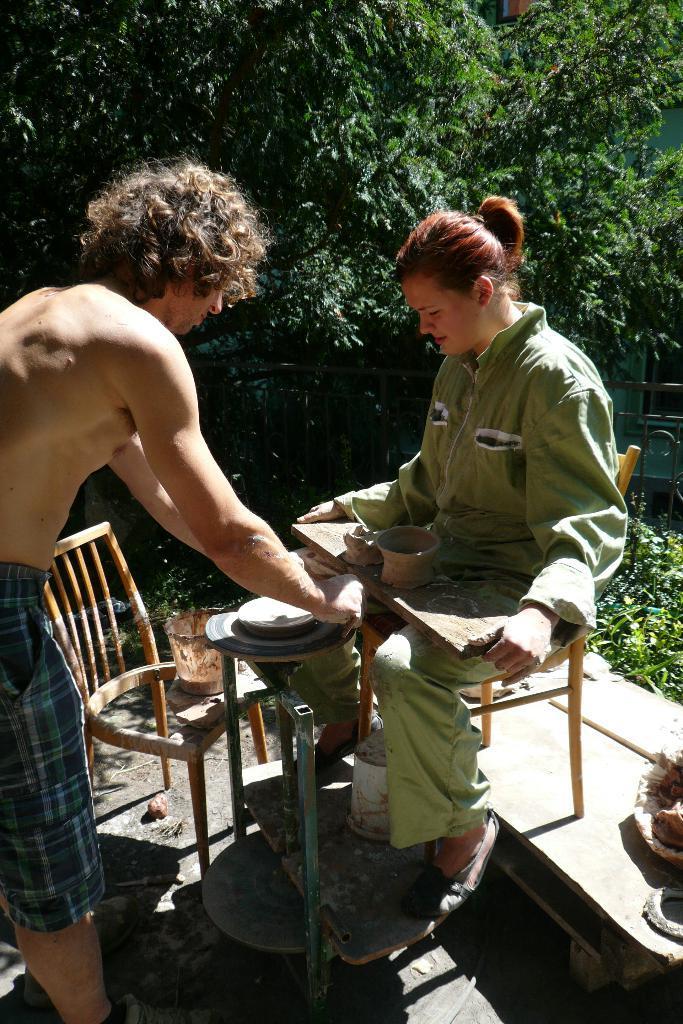Can you describe this image briefly? In this picture we can see a woman sitting on a chair and a man standing on the floor, bucket and in the background we can see trees. 